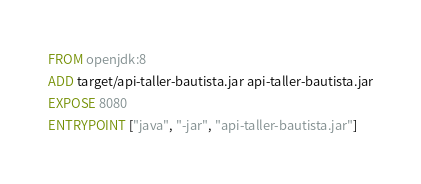Convert code to text. <code><loc_0><loc_0><loc_500><loc_500><_Dockerfile_>FROM openjdk:8
ADD target/api-taller-bautista.jar api-taller-bautista.jar
EXPOSE 8080
ENTRYPOINT ["java", "-jar", "api-taller-bautista.jar"]</code> 